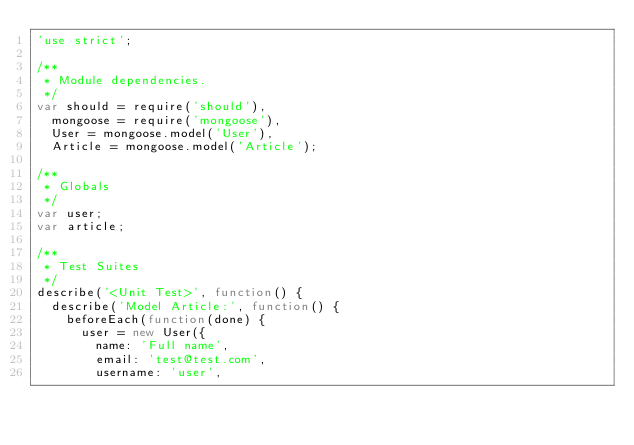<code> <loc_0><loc_0><loc_500><loc_500><_JavaScript_>'use strict';

/**
 * Module dependencies.
 */
var should = require('should'),
  mongoose = require('mongoose'),
  User = mongoose.model('User'),
  Article = mongoose.model('Article');

/**
 * Globals
 */
var user;
var article;

/**
 * Test Suites
 */
describe('<Unit Test>', function() {
  describe('Model Article:', function() {
    beforeEach(function(done) {
      user = new User({
        name: 'Full name',
        email: 'test@test.com',
        username: 'user',</code> 